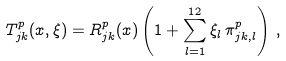Convert formula to latex. <formula><loc_0><loc_0><loc_500><loc_500>T ^ { p } _ { j k } ( x , \xi ) = R ^ { p } _ { j k } ( x ) \left ( 1 + \sum _ { l = 1 } ^ { 1 2 } \xi _ { l } \, \pi ^ { p } _ { j k , l } \right ) \, ,</formula> 